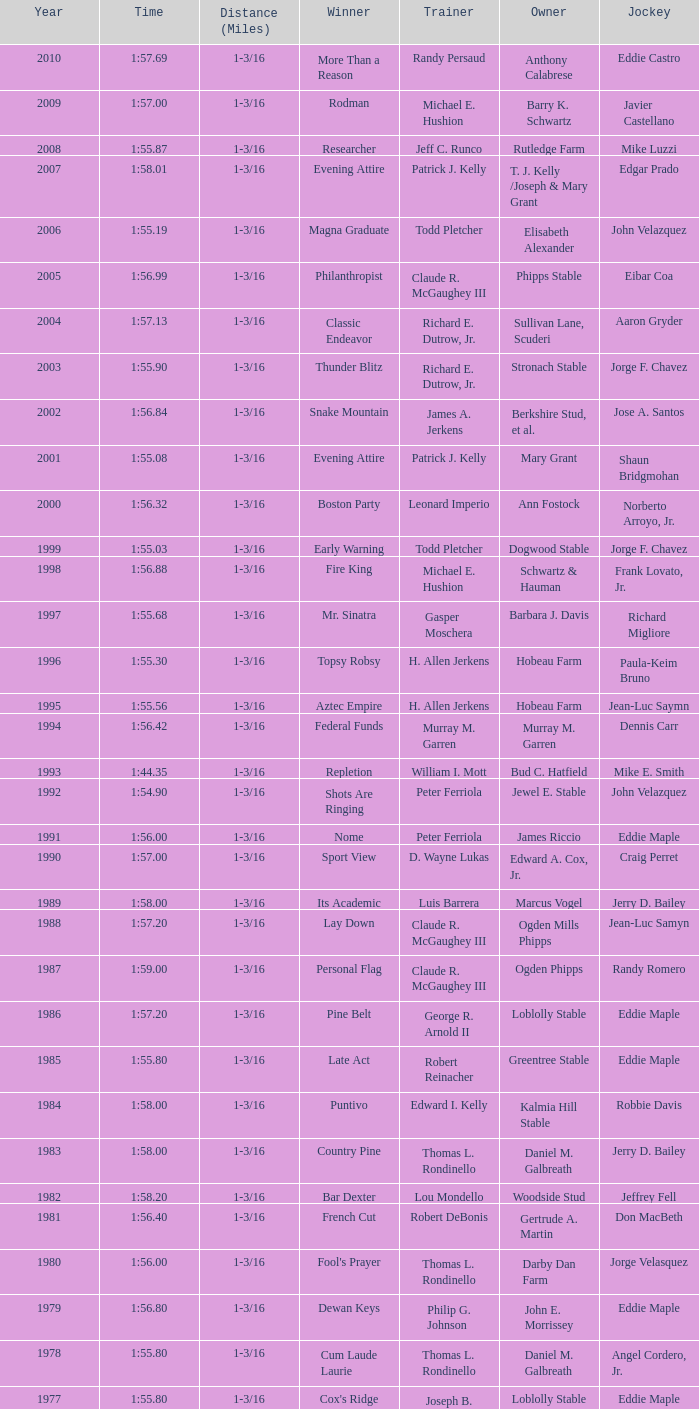What was the time for the winning horse Salford ii? 1:44.20. 